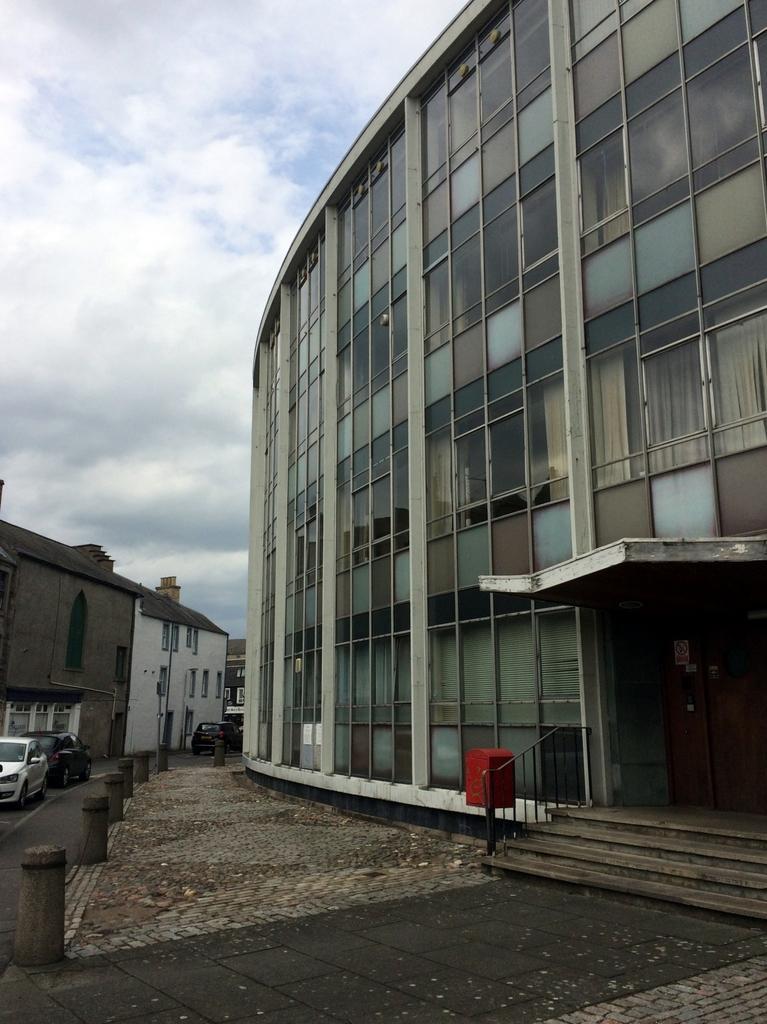In one or two sentences, can you explain what this image depicts? This image is taken outdoors. At the top of the image there is the sky with clouds. At the bottom of the image there is a floor. On the left side of the image there are a few buildings with walls, windows, doors and roofs. Two cars are parked on the road. On the right side of the image there is a building. There is a railing. There is a letter box and there are a few stairs. 